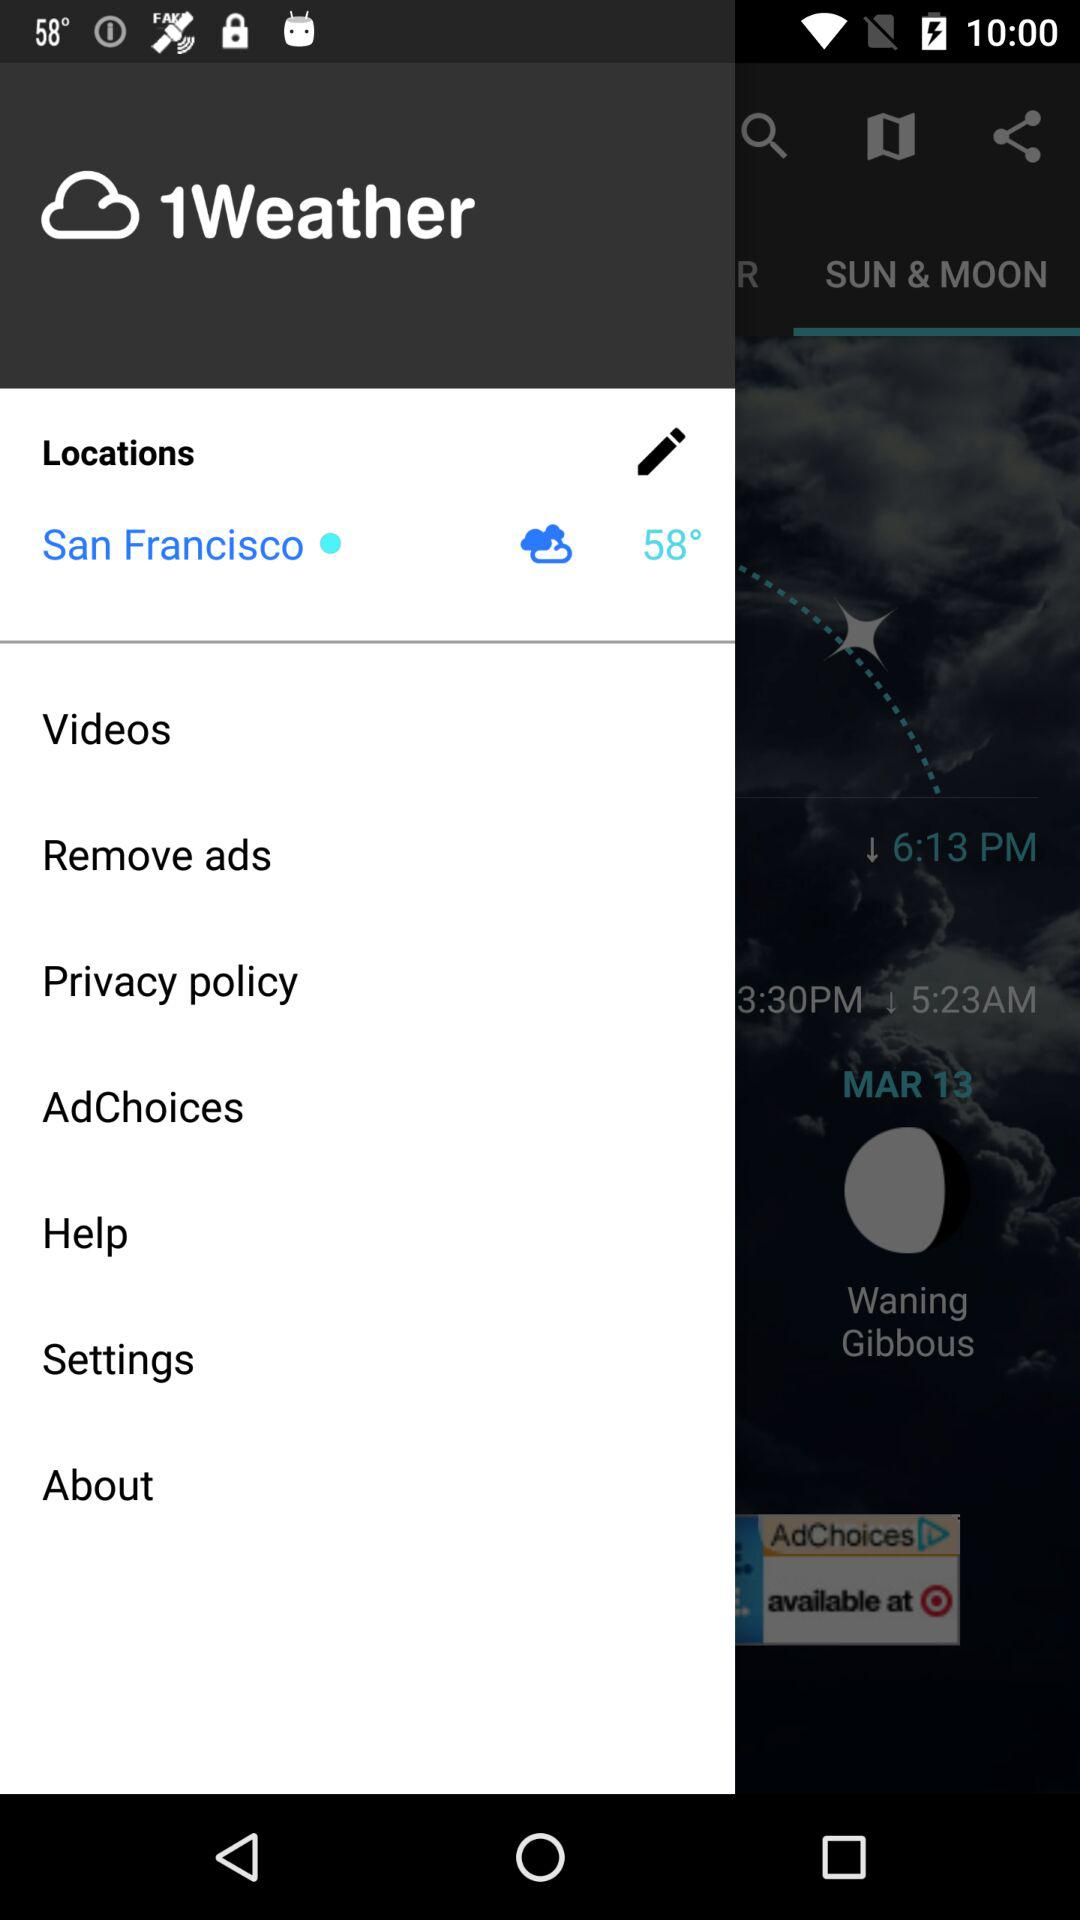What is the location? The location is San Francisco. 